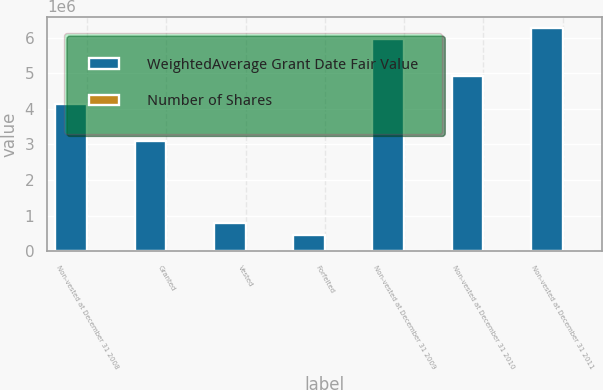<chart> <loc_0><loc_0><loc_500><loc_500><stacked_bar_chart><ecel><fcel>Non-vested at December 31 2008<fcel>Granted<fcel>Vested<fcel>Forfeited<fcel>Non-vested at December 31 2009<fcel>Non-vested at December 31 2010<fcel>Non-vested at December 31 2011<nl><fcel>WeightedAverage Grant Date Fair Value<fcel>4.12391e+06<fcel>3.10042e+06<fcel>804229<fcel>455503<fcel>5.96459e+06<fcel>4.93044e+06<fcel>6.28036e+06<nl><fcel>Number of Shares<fcel>27.67<fcel>2.87<fcel>16.39<fcel>16.47<fcel>17.15<fcel>12.13<fcel>7.6<nl></chart> 